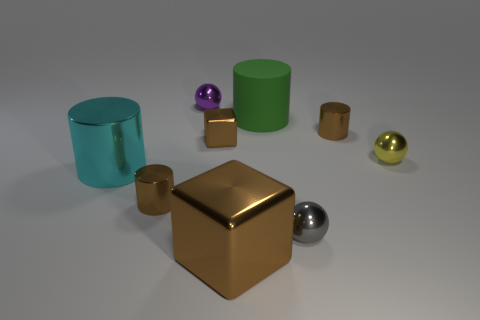Subtract all yellow cylinders. Subtract all green spheres. How many cylinders are left? 4 Add 1 tiny green cubes. How many objects exist? 10 Subtract all cylinders. How many objects are left? 5 Subtract 1 gray balls. How many objects are left? 8 Subtract all small red objects. Subtract all large metal things. How many objects are left? 7 Add 4 brown cylinders. How many brown cylinders are left? 6 Add 9 small gray metal spheres. How many small gray metal spheres exist? 10 